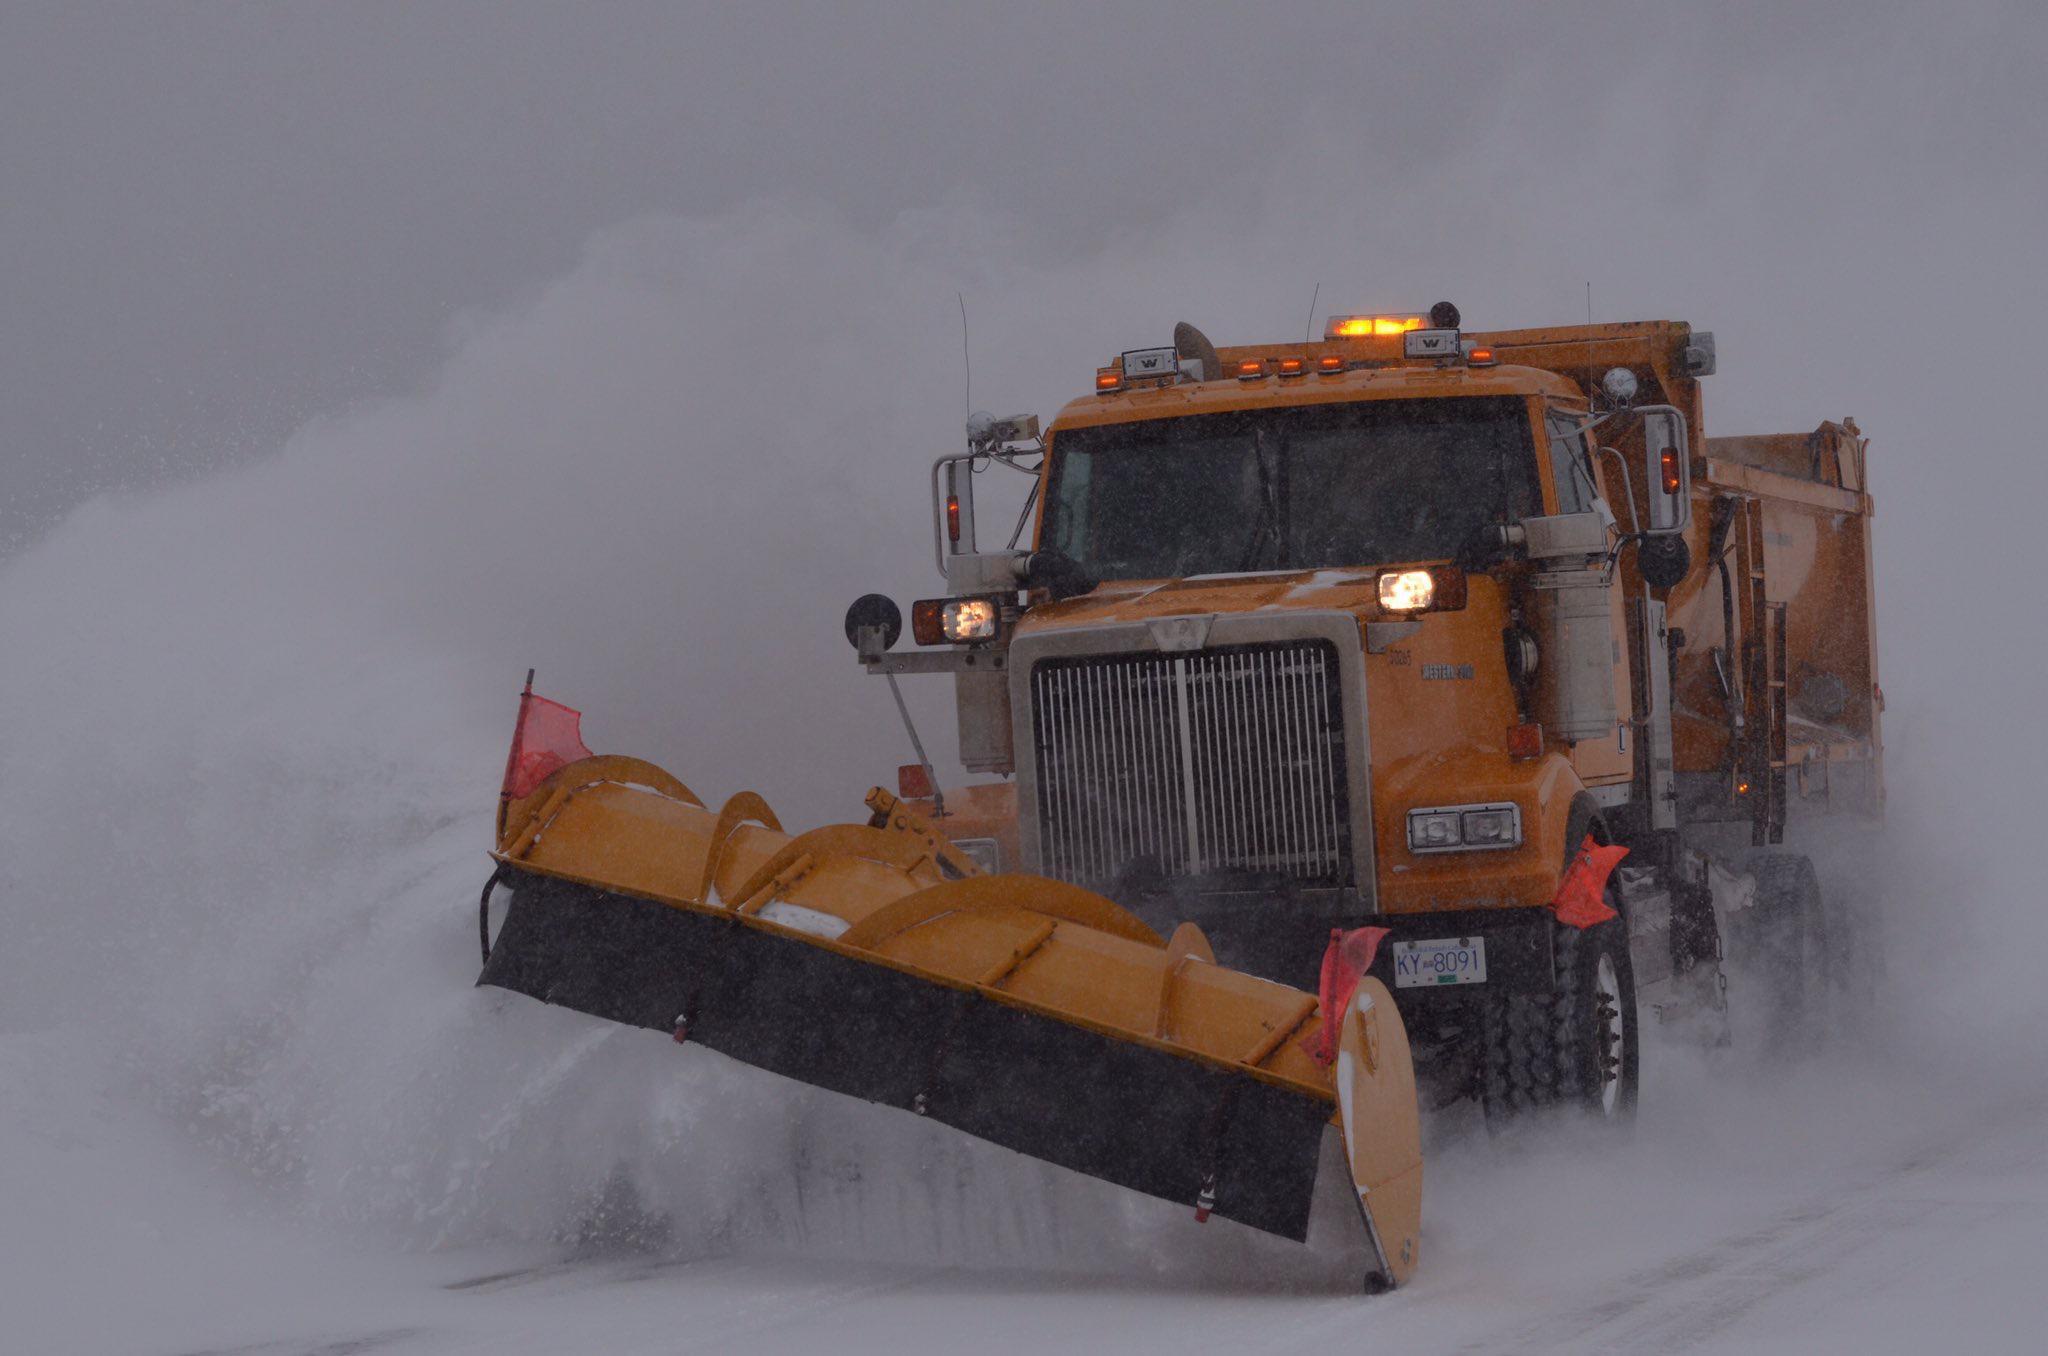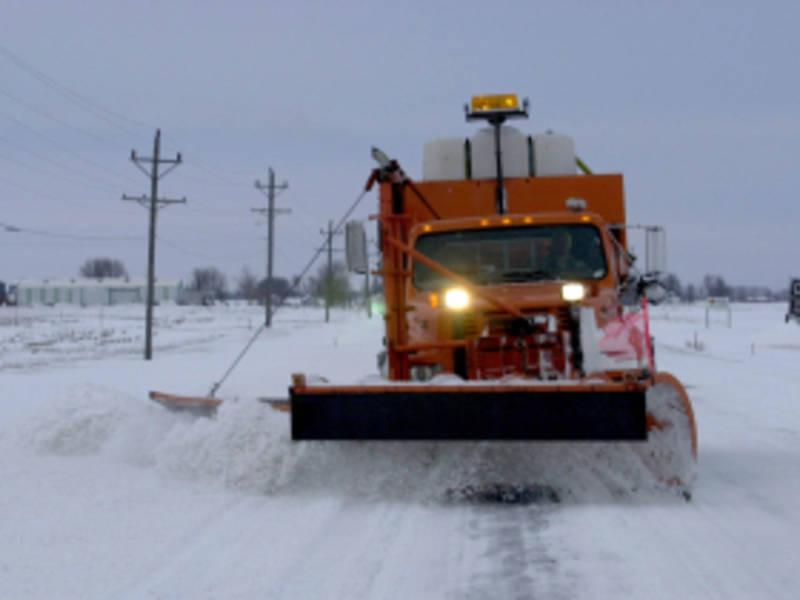The first image is the image on the left, the second image is the image on the right. For the images displayed, is the sentence "At least one of the vehicles has its shovel tilted with the left side higher than the right" factually correct? Answer yes or no. Yes. The first image is the image on the left, the second image is the image on the right. For the images shown, is this caption "The left and right image contains the same number of orange snow trucks." true? Answer yes or no. Yes. 